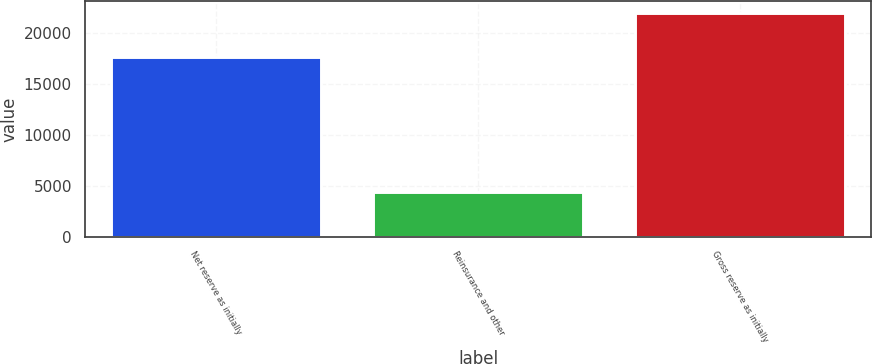Convert chart. <chart><loc_0><loc_0><loc_500><loc_500><bar_chart><fcel>Net reserve as initially<fcel>Reinsurance and other<fcel>Gross reserve as initially<nl><fcel>17604<fcel>4387<fcel>21991<nl></chart> 